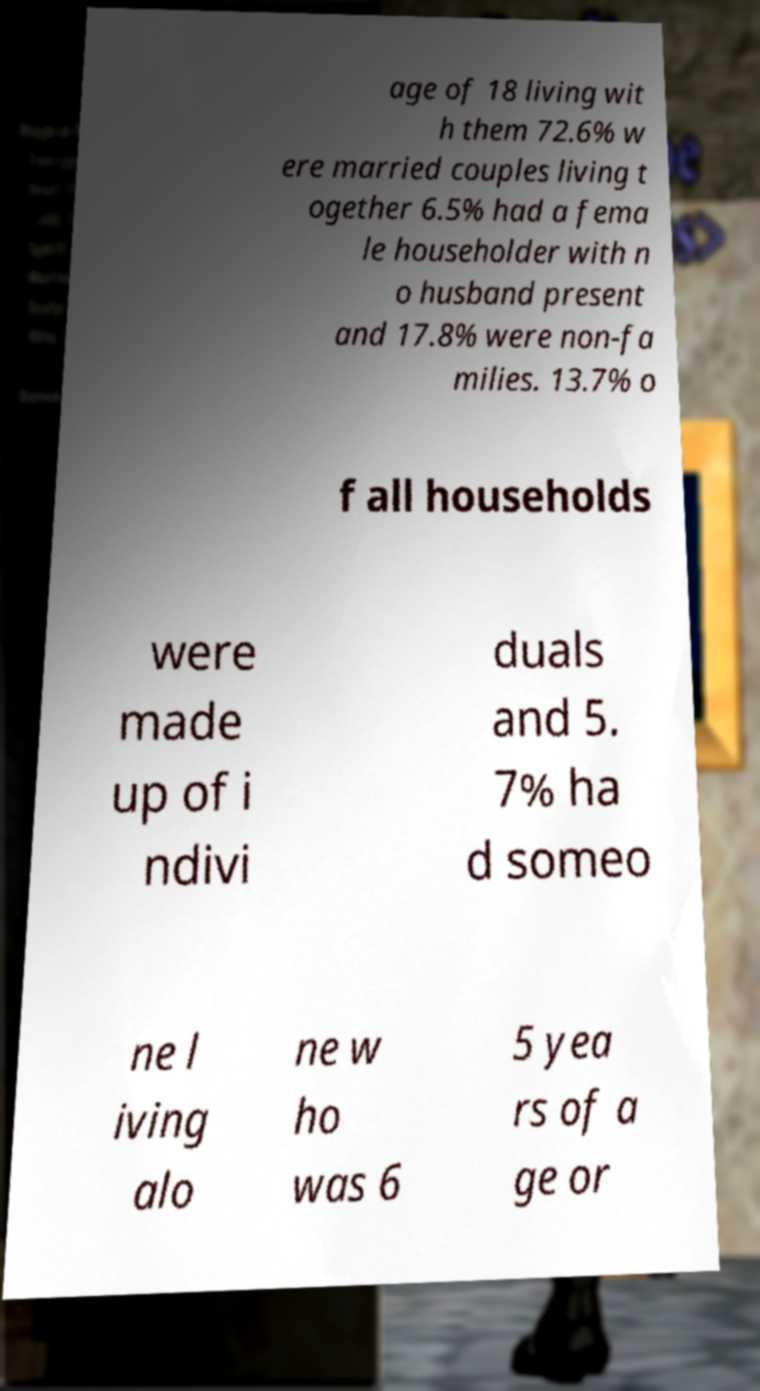What messages or text are displayed in this image? I need them in a readable, typed format. age of 18 living wit h them 72.6% w ere married couples living t ogether 6.5% had a fema le householder with n o husband present and 17.8% were non-fa milies. 13.7% o f all households were made up of i ndivi duals and 5. 7% ha d someo ne l iving alo ne w ho was 6 5 yea rs of a ge or 